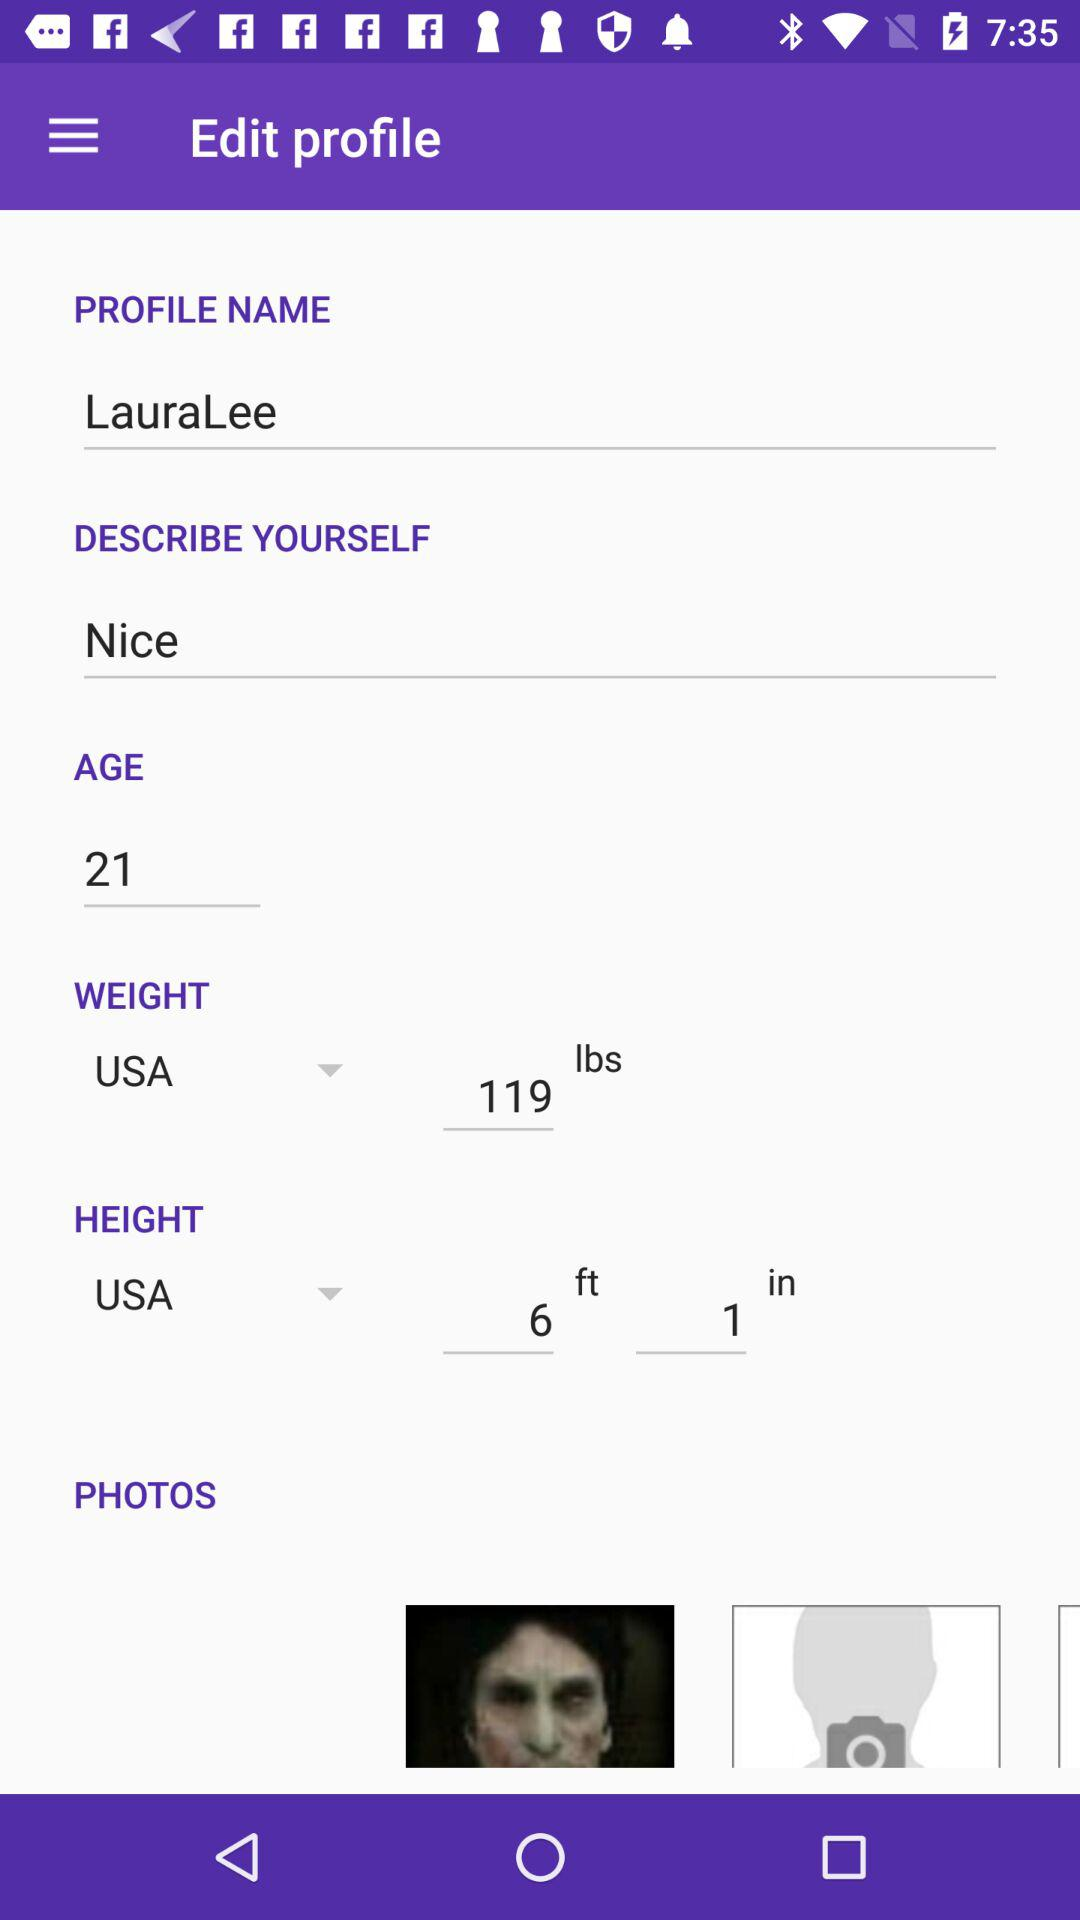What is the given profile name? The given profile name is LauraLee. 